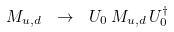Convert formula to latex. <formula><loc_0><loc_0><loc_500><loc_500>M _ { u , d } \ \rightarrow \ U _ { 0 } \, M _ { u , d } \, U _ { 0 } ^ { \dag }</formula> 